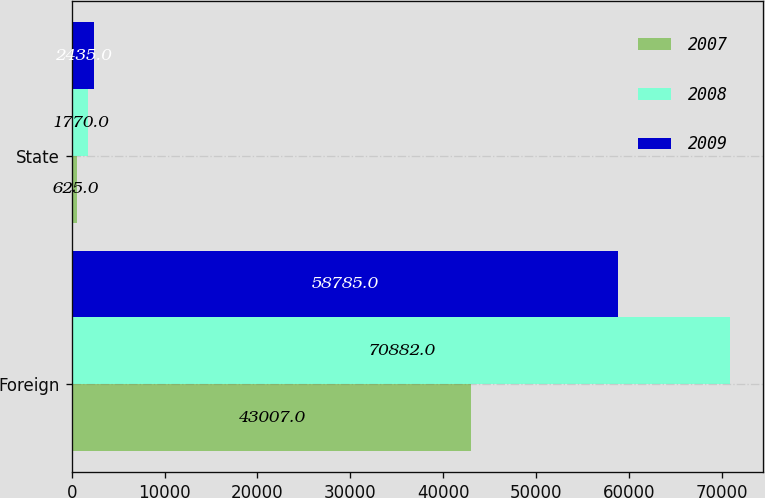<chart> <loc_0><loc_0><loc_500><loc_500><stacked_bar_chart><ecel><fcel>Foreign<fcel>State<nl><fcel>2007<fcel>43007<fcel>625<nl><fcel>2008<fcel>70882<fcel>1770<nl><fcel>2009<fcel>58785<fcel>2435<nl></chart> 